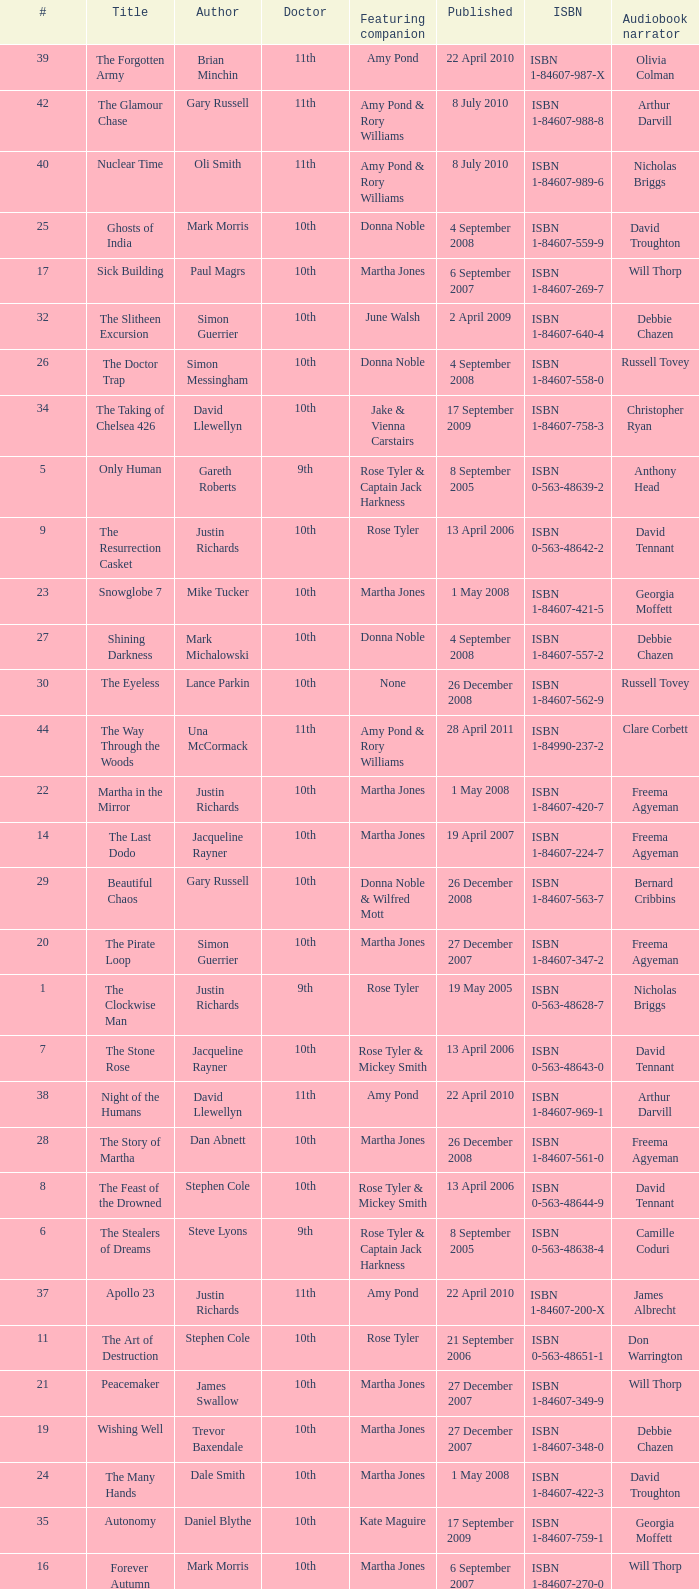What is the title of book number 7? The Stone Rose. 